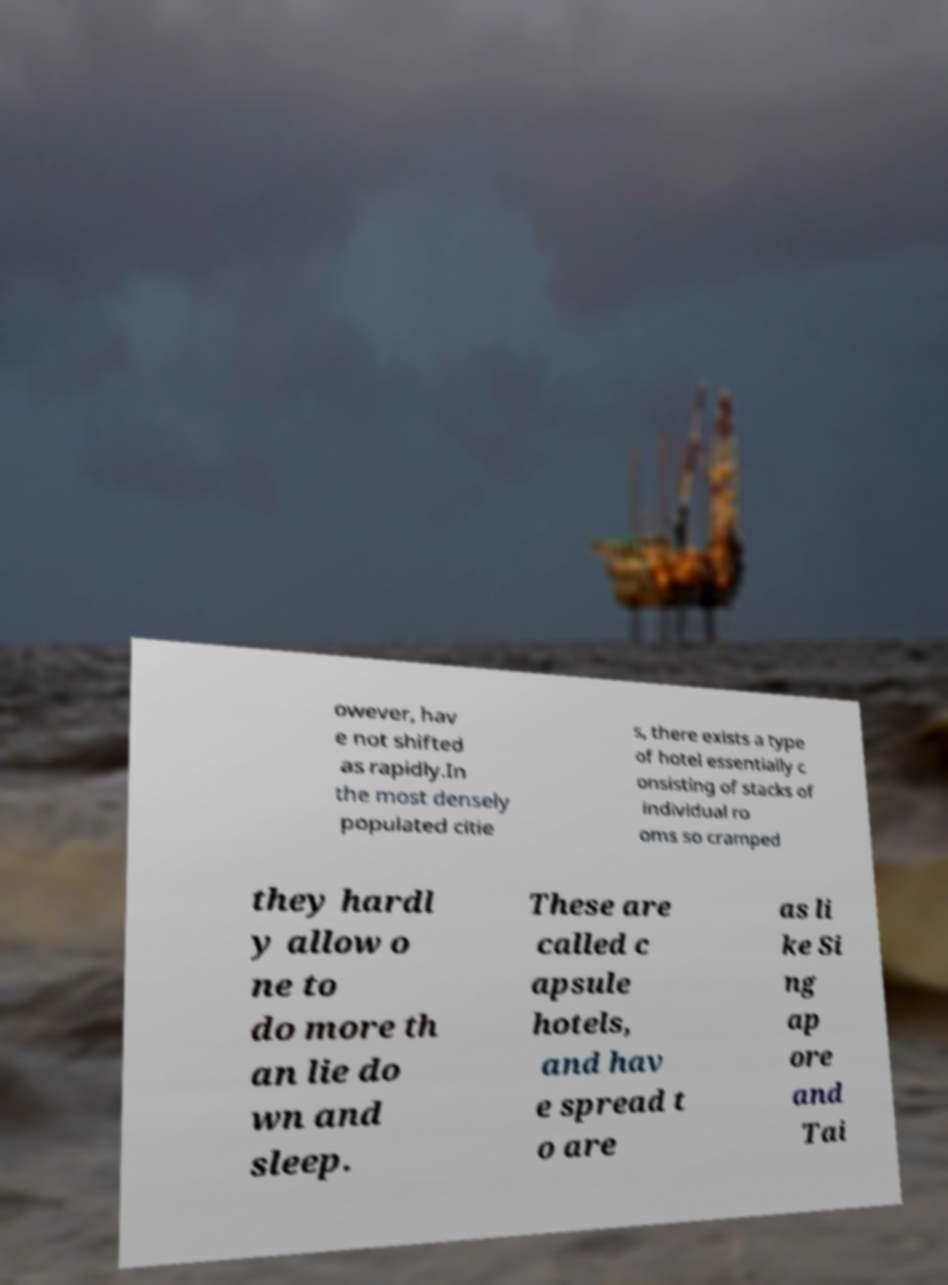Can you read and provide the text displayed in the image?This photo seems to have some interesting text. Can you extract and type it out for me? owever, hav e not shifted as rapidly.In the most densely populated citie s, there exists a type of hotel essentially c onsisting of stacks of individual ro oms so cramped they hardl y allow o ne to do more th an lie do wn and sleep. These are called c apsule hotels, and hav e spread t o are as li ke Si ng ap ore and Tai 